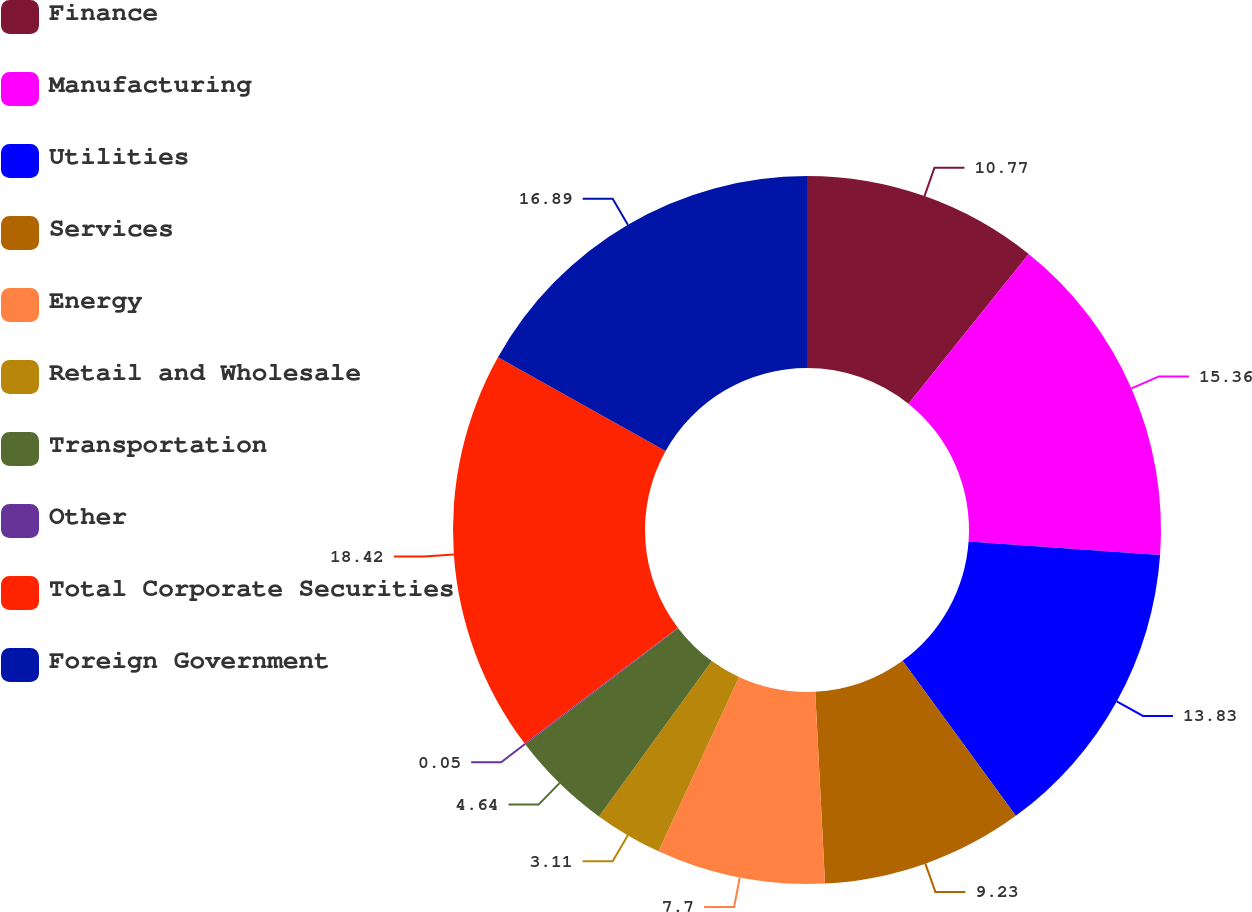Convert chart to OTSL. <chart><loc_0><loc_0><loc_500><loc_500><pie_chart><fcel>Finance<fcel>Manufacturing<fcel>Utilities<fcel>Services<fcel>Energy<fcel>Retail and Wholesale<fcel>Transportation<fcel>Other<fcel>Total Corporate Securities<fcel>Foreign Government<nl><fcel>10.77%<fcel>15.36%<fcel>13.83%<fcel>9.23%<fcel>7.7%<fcel>3.11%<fcel>4.64%<fcel>0.05%<fcel>18.42%<fcel>16.89%<nl></chart> 